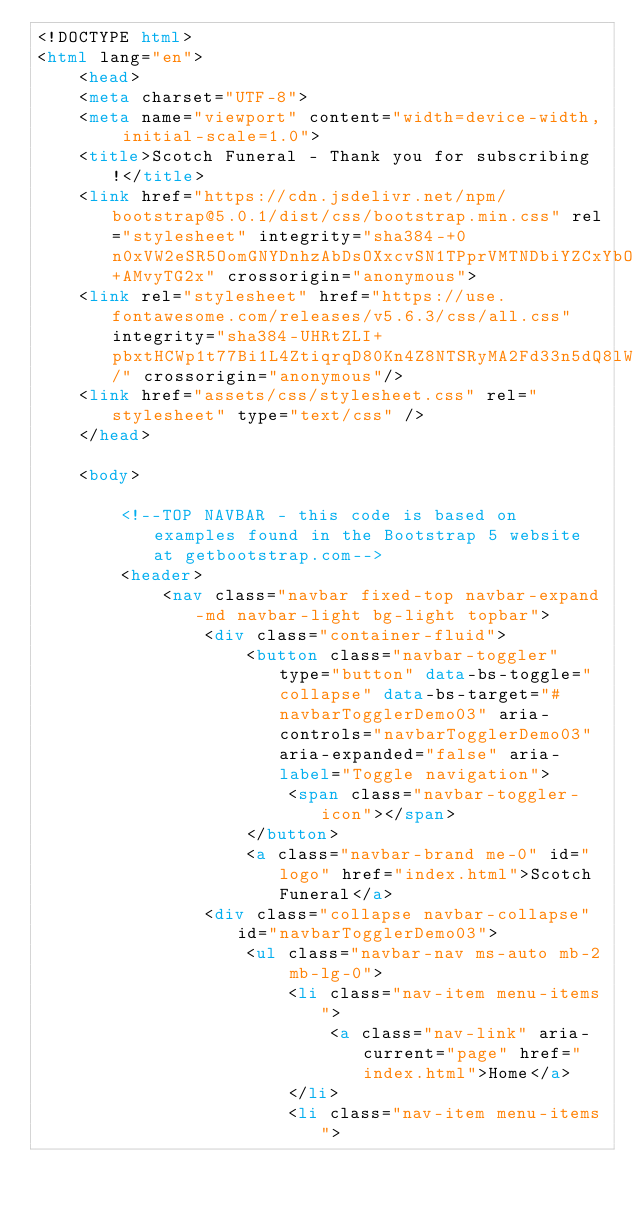<code> <loc_0><loc_0><loc_500><loc_500><_HTML_><!DOCTYPE html>
<html lang="en">
    <head>
    <meta charset="UTF-8">
    <meta name="viewport" content="width=device-width, initial-scale=1.0">
    <title>Scotch Funeral - Thank you for subscribing!</title>
    <link href="https://cdn.jsdelivr.net/npm/bootstrap@5.0.1/dist/css/bootstrap.min.css" rel="stylesheet" integrity="sha384-+0n0xVW2eSR5OomGNYDnhzAbDsOXxcvSN1TPprVMTNDbiYZCxYbOOl7+AMvyTG2x" crossorigin="anonymous">
    <link rel="stylesheet" href="https://use.fontawesome.com/releases/v5.6.3/css/all.css" integrity="sha384-UHRtZLI+pbxtHCWp1t77Bi1L4ZtiqrqD80Kn4Z8NTSRyMA2Fd33n5dQ8lWUE00s/" crossorigin="anonymous"/>
    <link href="assets/css/stylesheet.css" rel="stylesheet" type="text/css" />
    </head>
        
    <body>
    
        <!--TOP NAVBAR - this code is based on examples found in the Bootstrap 5 website at getbootstrap.com-->
        <header>
            <nav class="navbar fixed-top navbar-expand-md navbar-light bg-light topbar">
                <div class="container-fluid">
                    <button class="navbar-toggler" type="button" data-bs-toggle="collapse" data-bs-target="#navbarTogglerDemo03" aria-controls="navbarTogglerDemo03" aria-expanded="false" aria-label="Toggle navigation">
                        <span class="navbar-toggler-icon"></span>
                    </button>
                    <a class="navbar-brand me-0" id="logo" href="index.html">Scotch Funeral</a>
                <div class="collapse navbar-collapse" id="navbarTogglerDemo03">
                    <ul class="navbar-nav ms-auto mb-2 mb-lg-0">
                        <li class="nav-item menu-items">
                            <a class="nav-link" aria-current="page" href="index.html">Home</a>
                        </li>
                        <li class="nav-item menu-items"></code> 